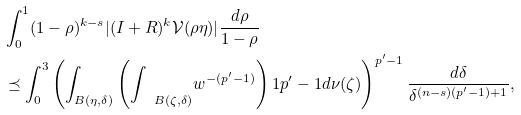<formula> <loc_0><loc_0><loc_500><loc_500>& \int _ { 0 } ^ { 1 } ( 1 - \rho ) ^ { k - s } | ( I + R ) ^ { k } { \mathcal { V } } ( \rho \eta ) | \frac { d \rho } { 1 - \rho } \\ & \preceq \int _ { 0 } ^ { 3 } \left ( \int _ { B ( \eta , \delta ) } \left ( { \int \, \ } _ { B ( \zeta , \delta ) } w ^ { - ( p ^ { \prime } - 1 ) } \right ) ^ { } { 1 } { p ^ { \prime } - 1 } d \nu ( \zeta ) \right ) ^ { p ^ { \prime } - 1 } \frac { d \delta } { \delta ^ { ( n - s ) ( p ^ { \prime } - 1 ) + 1 } } ,</formula> 